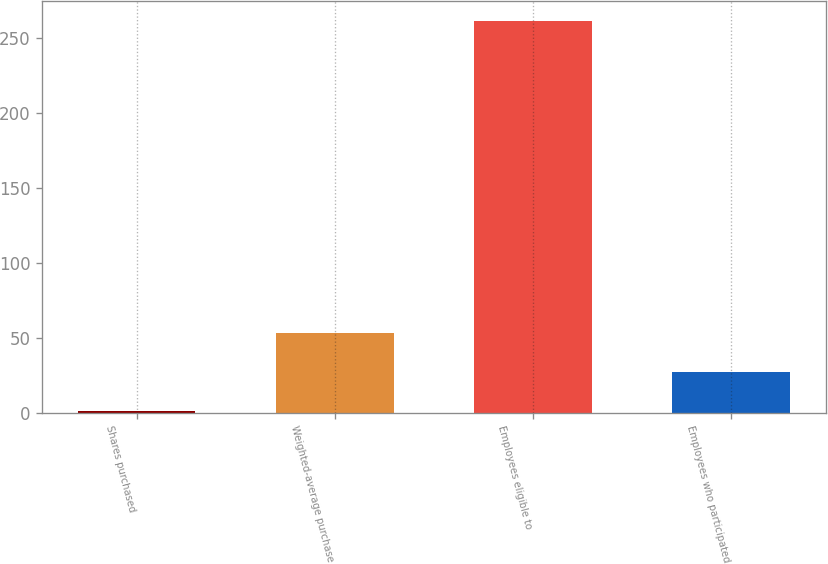<chart> <loc_0><loc_0><loc_500><loc_500><bar_chart><fcel>Shares purchased<fcel>Weighted-average purchase<fcel>Employees eligible to<fcel>Employees who participated<nl><fcel>1.75<fcel>53.61<fcel>261<fcel>27.68<nl></chart> 